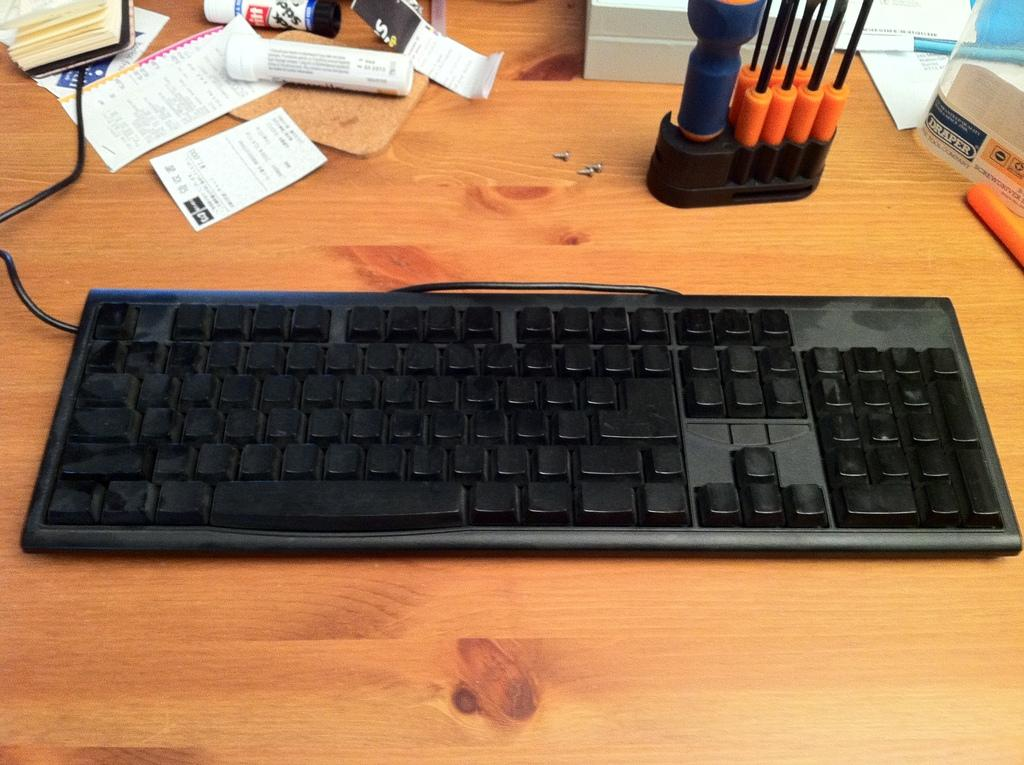Provide a one-sentence caption for the provided image. The label for a product from Draper is visible at the edge of a desktop. 